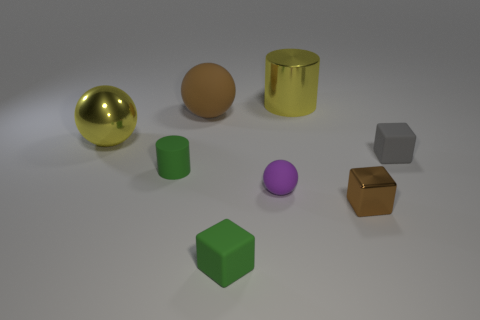Add 1 yellow metal cylinders. How many objects exist? 9 Subtract all cylinders. How many objects are left? 6 Add 6 large yellow metal things. How many large yellow metal things are left? 8 Add 8 green cylinders. How many green cylinders exist? 9 Subtract 0 red cubes. How many objects are left? 8 Subtract all small yellow rubber blocks. Subtract all metallic blocks. How many objects are left? 7 